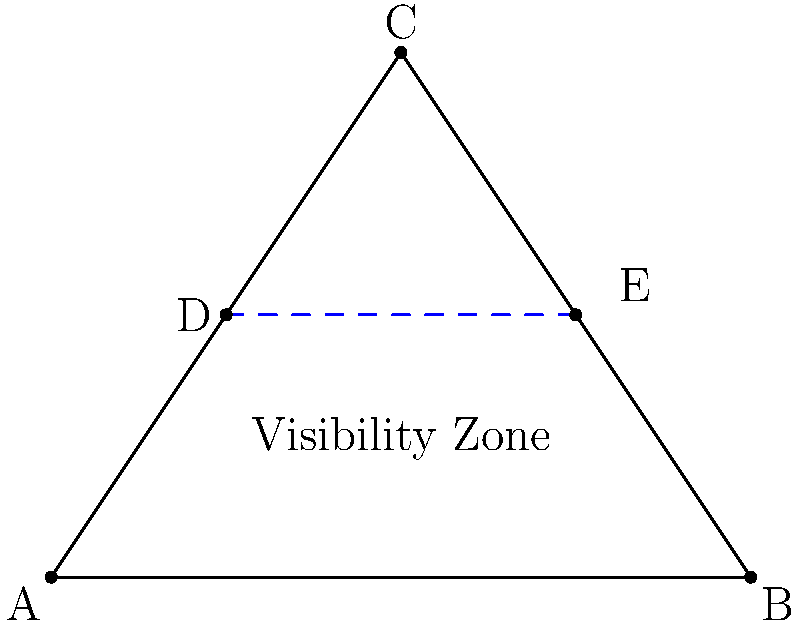Given a triangular map ABC with a unit stationed at point D(1,1.5), calculate the optimal vector for the unit to move to maximize map visibility. The visibility zone is represented by the line DE, where E is (3,1.5). What is the magnitude and direction of the vector from D to the point that maximizes visibility? To maximize map visibility, we need to move the unit to a position that allows it to see the largest area of the map. In this case, the optimal position would be at the center of the visibility zone.

Step 1: Identify the center of the visibility zone (line DE).
The center point is the midpoint of DE.

Step 2: Calculate the midpoint coordinates.
Midpoint = $(\frac{x_1 + x_2}{2}, \frac{y_1 + y_2}{2})$
$x_{midpoint} = \frac{1 + 3}{2} = 2$
$y_{midpoint} = \frac{1.5 + 1.5}{2} = 1.5$
Midpoint = (2, 1.5)

Step 3: Calculate the vector from D to the midpoint.
Vector = Midpoint - D
$\vec{v} = (2, 1.5) - (1, 1.5) = (1, 0)$

Step 4: Calculate the magnitude of the vector.
Magnitude = $\sqrt{x^2 + y^2} = \sqrt{1^2 + 0^2} = 1$

Step 5: Determine the direction of the vector.
The vector (1, 0) points in the positive x-direction, which is 0° or 360° in standard position.

Therefore, the optimal vector has a magnitude of 1 unit and a direction of 0° (or 360°).
Answer: 1 unit, 0° 